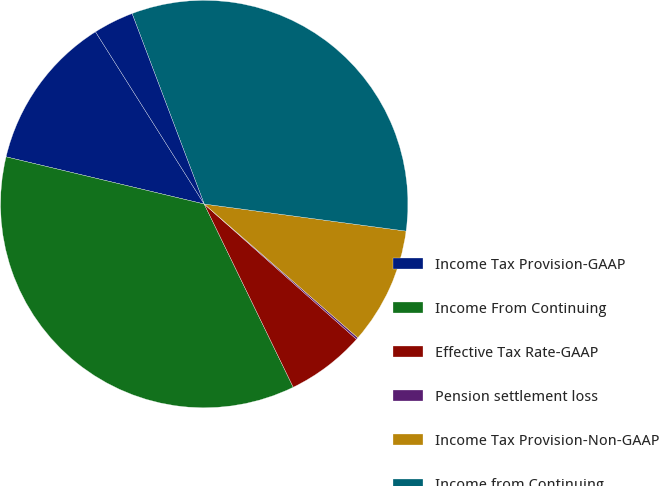Convert chart to OTSL. <chart><loc_0><loc_0><loc_500><loc_500><pie_chart><fcel>Income Tax Provision-GAAP<fcel>Income From Continuing<fcel>Effective Tax Rate-GAAP<fcel>Pension settlement loss<fcel>Income Tax Provision-Non-GAAP<fcel>Income from Continuing<fcel>Effective Tax Rate-Non-GAAP<nl><fcel>12.32%<fcel>35.93%<fcel>6.24%<fcel>0.16%<fcel>9.28%<fcel>32.89%<fcel>3.2%<nl></chart> 